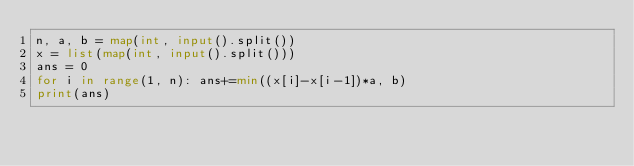Convert code to text. <code><loc_0><loc_0><loc_500><loc_500><_Python_>n, a, b = map(int, input().split())
x = list(map(int, input().split()))
ans = 0
for i in range(1, n): ans+=min((x[i]-x[i-1])*a, b)
print(ans)</code> 